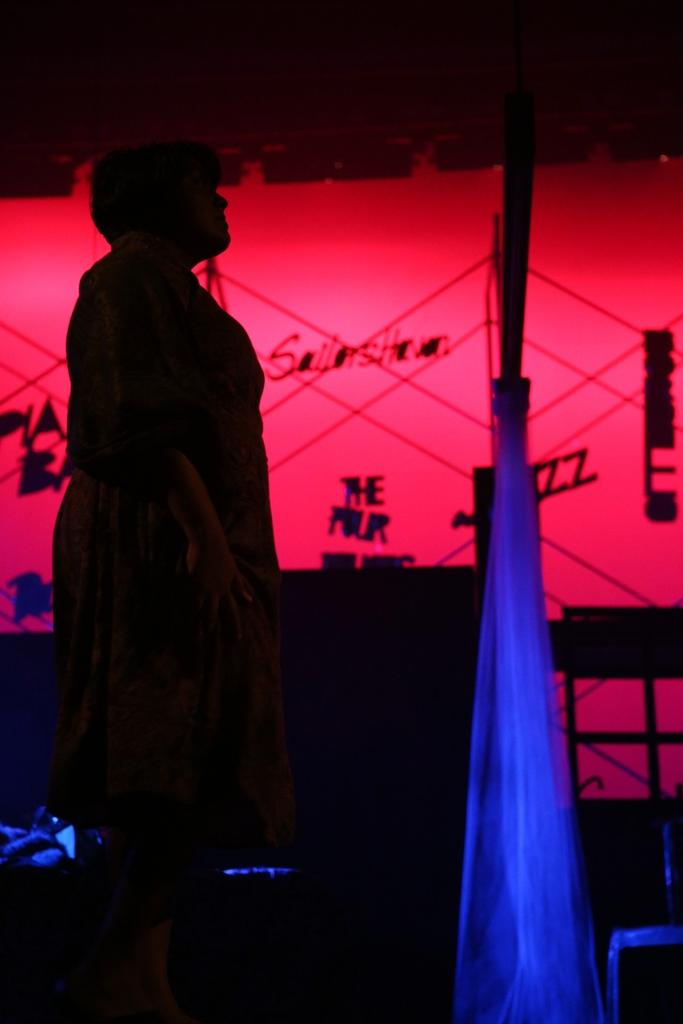What is the general setting or location depicted in the image? There is a dark place in the image. Is there anyone present in the dark place? Yes, there is a person in the dark place. What else can be seen in the image besides the person and the dark place? There is a poster in the image. What is depicted on the poster? The poster has some things on it. What type of jeans is the person wearing in the image? There is no information about the person's clothing, including jeans, in the image. What country is depicted on the poster? There is no country depicted on the poster; it only has some things on it. 